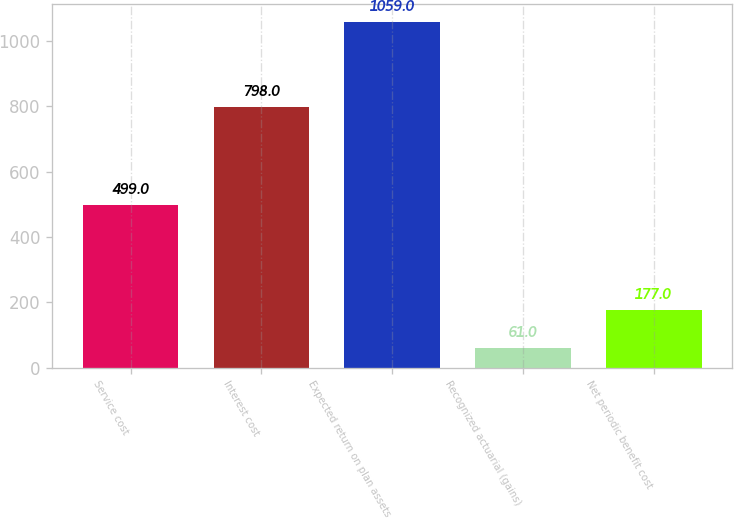Convert chart. <chart><loc_0><loc_0><loc_500><loc_500><bar_chart><fcel>Service cost<fcel>Interest cost<fcel>Expected return on plan assets<fcel>Recognized actuarial (gains)<fcel>Net periodic benefit cost<nl><fcel>499<fcel>798<fcel>1059<fcel>61<fcel>177<nl></chart> 